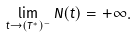Convert formula to latex. <formula><loc_0><loc_0><loc_500><loc_500>\lim _ { t \rightarrow ( T ^ { * } ) ^ { - } } N ( t ) = + \infty .</formula> 